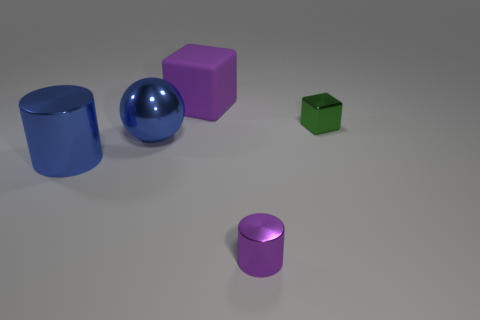If we were to categorize these objects by shape, how would you group them? Based on their shapes, we could group these objects into two categories. The first category includes the cylindrical shapes, which are represented by the blue cylinder and the smaller purple cylinder. The second category consists of the cubical shapes, including the purple cube and the green cube. The blue sphere stands alone in its own spherical category. 